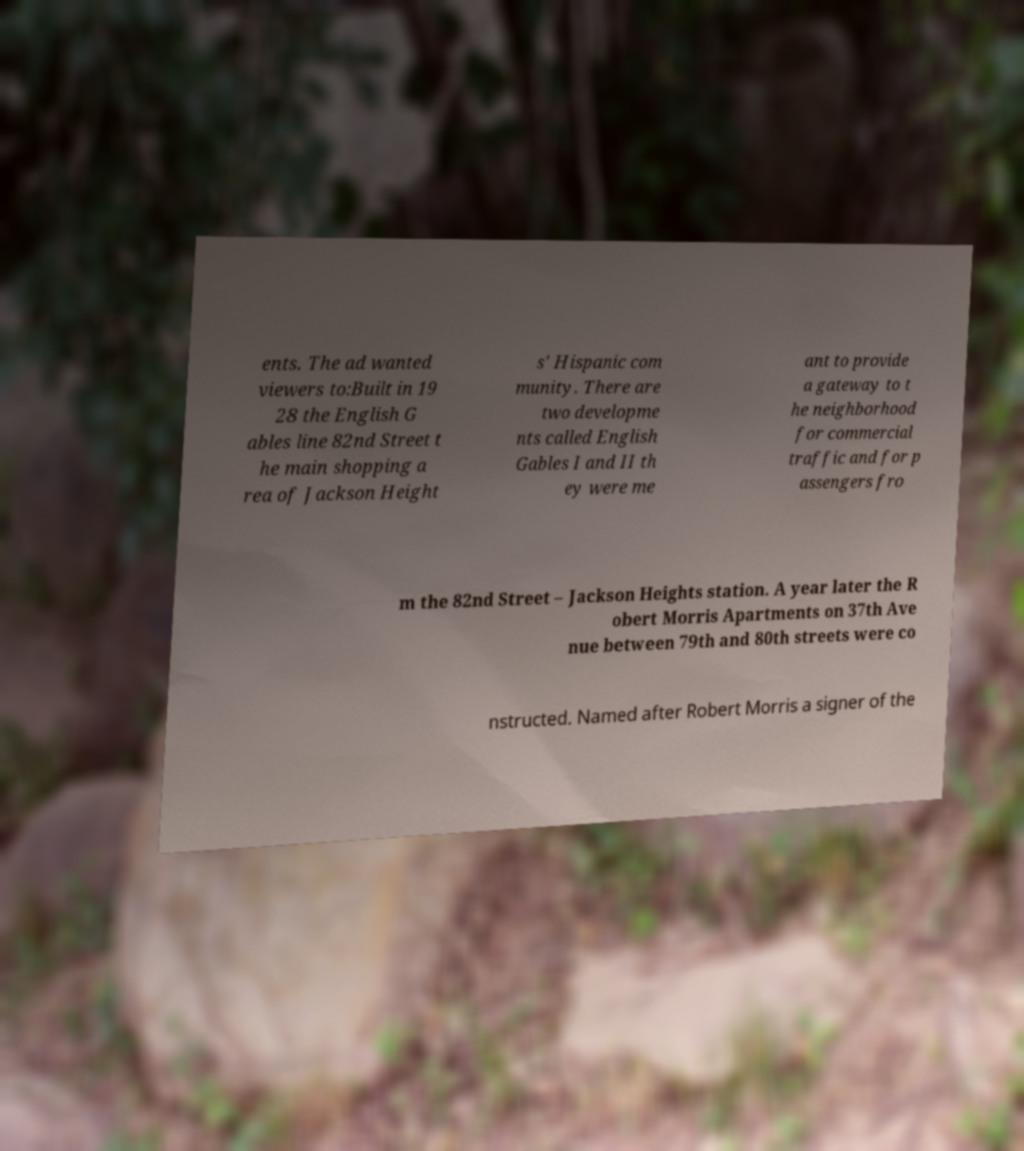Can you read and provide the text displayed in the image?This photo seems to have some interesting text. Can you extract and type it out for me? ents. The ad wanted viewers to:Built in 19 28 the English G ables line 82nd Street t he main shopping a rea of Jackson Height s' Hispanic com munity. There are two developme nts called English Gables I and II th ey were me ant to provide a gateway to t he neighborhood for commercial traffic and for p assengers fro m the 82nd Street – Jackson Heights station. A year later the R obert Morris Apartments on 37th Ave nue between 79th and 80th streets were co nstructed. Named after Robert Morris a signer of the 